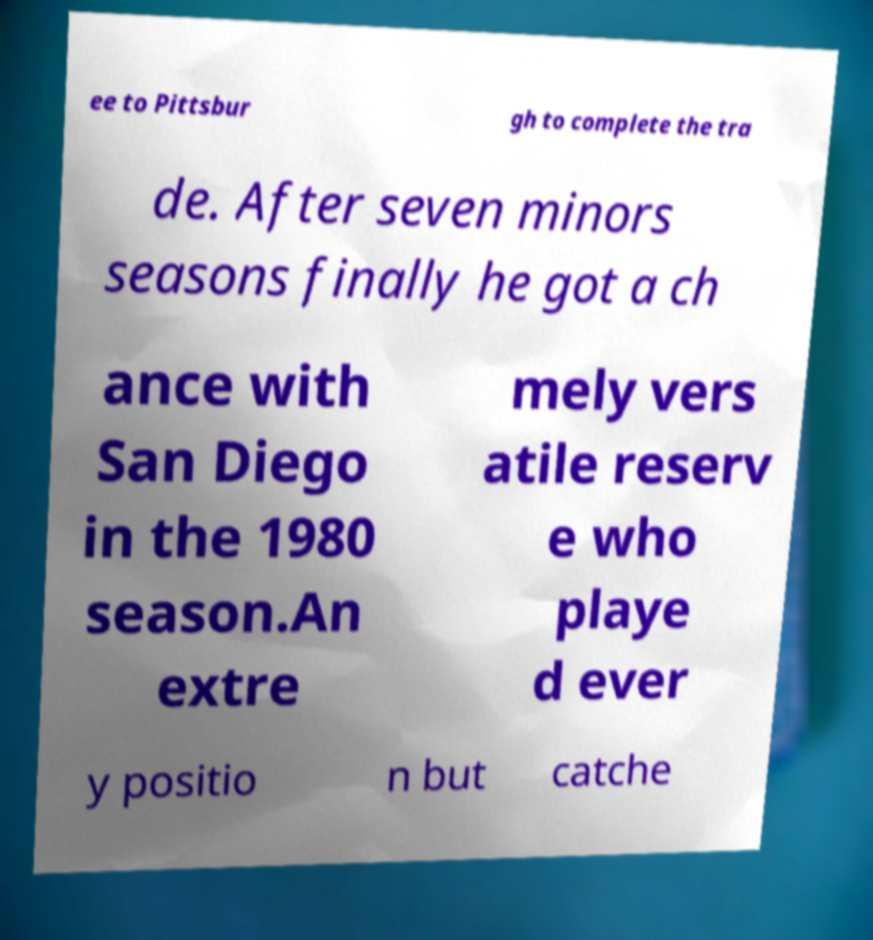I need the written content from this picture converted into text. Can you do that? ee to Pittsbur gh to complete the tra de. After seven minors seasons finally he got a ch ance with San Diego in the 1980 season.An extre mely vers atile reserv e who playe d ever y positio n but catche 